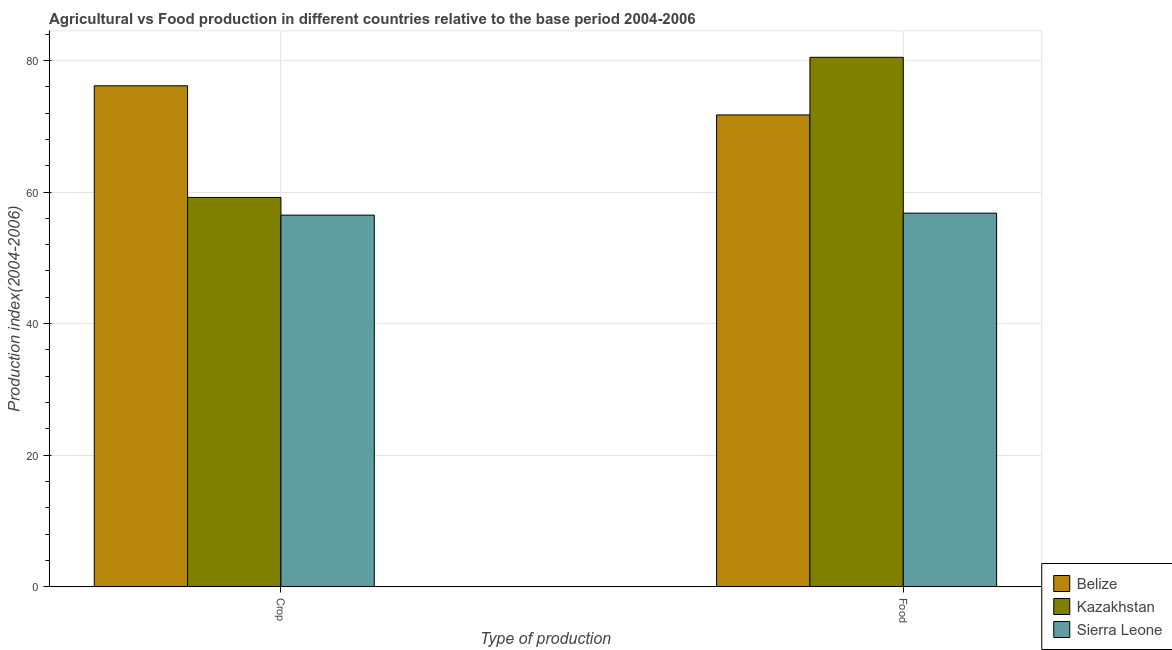What is the label of the 2nd group of bars from the left?
Your answer should be very brief. Food. What is the crop production index in Sierra Leone?
Your answer should be very brief. 56.49. Across all countries, what is the maximum food production index?
Your answer should be compact. 80.48. Across all countries, what is the minimum food production index?
Offer a very short reply. 56.79. In which country was the food production index maximum?
Your answer should be compact. Kazakhstan. In which country was the food production index minimum?
Your answer should be compact. Sierra Leone. What is the total crop production index in the graph?
Provide a short and direct response. 191.82. What is the difference between the food production index in Sierra Leone and that in Kazakhstan?
Make the answer very short. -23.69. What is the difference between the crop production index in Kazakhstan and the food production index in Sierra Leone?
Offer a terse response. 2.39. What is the average crop production index per country?
Your response must be concise. 63.94. What is the difference between the crop production index and food production index in Sierra Leone?
Your response must be concise. -0.3. What is the ratio of the food production index in Sierra Leone to that in Kazakhstan?
Your answer should be compact. 0.71. Is the crop production index in Sierra Leone less than that in Belize?
Offer a very short reply. Yes. What does the 2nd bar from the left in Food represents?
Offer a terse response. Kazakhstan. What does the 3rd bar from the right in Food represents?
Make the answer very short. Belize. How many bars are there?
Your answer should be compact. 6. How many countries are there in the graph?
Your answer should be very brief. 3. What is the difference between two consecutive major ticks on the Y-axis?
Your answer should be very brief. 20. Are the values on the major ticks of Y-axis written in scientific E-notation?
Offer a very short reply. No. Does the graph contain any zero values?
Your answer should be very brief. No. How many legend labels are there?
Offer a terse response. 3. What is the title of the graph?
Offer a terse response. Agricultural vs Food production in different countries relative to the base period 2004-2006. What is the label or title of the X-axis?
Give a very brief answer. Type of production. What is the label or title of the Y-axis?
Offer a terse response. Production index(2004-2006). What is the Production index(2004-2006) of Belize in Crop?
Offer a terse response. 76.15. What is the Production index(2004-2006) of Kazakhstan in Crop?
Give a very brief answer. 59.18. What is the Production index(2004-2006) of Sierra Leone in Crop?
Your answer should be very brief. 56.49. What is the Production index(2004-2006) of Belize in Food?
Keep it short and to the point. 71.72. What is the Production index(2004-2006) of Kazakhstan in Food?
Provide a short and direct response. 80.48. What is the Production index(2004-2006) in Sierra Leone in Food?
Your answer should be compact. 56.79. Across all Type of production, what is the maximum Production index(2004-2006) in Belize?
Keep it short and to the point. 76.15. Across all Type of production, what is the maximum Production index(2004-2006) in Kazakhstan?
Give a very brief answer. 80.48. Across all Type of production, what is the maximum Production index(2004-2006) in Sierra Leone?
Provide a succinct answer. 56.79. Across all Type of production, what is the minimum Production index(2004-2006) in Belize?
Your answer should be compact. 71.72. Across all Type of production, what is the minimum Production index(2004-2006) in Kazakhstan?
Ensure brevity in your answer.  59.18. Across all Type of production, what is the minimum Production index(2004-2006) in Sierra Leone?
Your answer should be very brief. 56.49. What is the total Production index(2004-2006) in Belize in the graph?
Your answer should be very brief. 147.87. What is the total Production index(2004-2006) in Kazakhstan in the graph?
Give a very brief answer. 139.66. What is the total Production index(2004-2006) in Sierra Leone in the graph?
Offer a very short reply. 113.28. What is the difference between the Production index(2004-2006) in Belize in Crop and that in Food?
Provide a succinct answer. 4.43. What is the difference between the Production index(2004-2006) of Kazakhstan in Crop and that in Food?
Provide a succinct answer. -21.3. What is the difference between the Production index(2004-2006) of Sierra Leone in Crop and that in Food?
Provide a succinct answer. -0.3. What is the difference between the Production index(2004-2006) in Belize in Crop and the Production index(2004-2006) in Kazakhstan in Food?
Provide a succinct answer. -4.33. What is the difference between the Production index(2004-2006) in Belize in Crop and the Production index(2004-2006) in Sierra Leone in Food?
Your answer should be very brief. 19.36. What is the difference between the Production index(2004-2006) of Kazakhstan in Crop and the Production index(2004-2006) of Sierra Leone in Food?
Offer a very short reply. 2.39. What is the average Production index(2004-2006) of Belize per Type of production?
Offer a very short reply. 73.94. What is the average Production index(2004-2006) in Kazakhstan per Type of production?
Ensure brevity in your answer.  69.83. What is the average Production index(2004-2006) of Sierra Leone per Type of production?
Your answer should be very brief. 56.64. What is the difference between the Production index(2004-2006) in Belize and Production index(2004-2006) in Kazakhstan in Crop?
Your answer should be very brief. 16.97. What is the difference between the Production index(2004-2006) of Belize and Production index(2004-2006) of Sierra Leone in Crop?
Provide a short and direct response. 19.66. What is the difference between the Production index(2004-2006) in Kazakhstan and Production index(2004-2006) in Sierra Leone in Crop?
Provide a short and direct response. 2.69. What is the difference between the Production index(2004-2006) in Belize and Production index(2004-2006) in Kazakhstan in Food?
Your answer should be very brief. -8.76. What is the difference between the Production index(2004-2006) of Belize and Production index(2004-2006) of Sierra Leone in Food?
Keep it short and to the point. 14.93. What is the difference between the Production index(2004-2006) of Kazakhstan and Production index(2004-2006) of Sierra Leone in Food?
Your answer should be compact. 23.69. What is the ratio of the Production index(2004-2006) of Belize in Crop to that in Food?
Provide a succinct answer. 1.06. What is the ratio of the Production index(2004-2006) in Kazakhstan in Crop to that in Food?
Offer a terse response. 0.74. What is the ratio of the Production index(2004-2006) of Sierra Leone in Crop to that in Food?
Give a very brief answer. 0.99. What is the difference between the highest and the second highest Production index(2004-2006) in Belize?
Provide a succinct answer. 4.43. What is the difference between the highest and the second highest Production index(2004-2006) in Kazakhstan?
Keep it short and to the point. 21.3. What is the difference between the highest and the lowest Production index(2004-2006) in Belize?
Offer a very short reply. 4.43. What is the difference between the highest and the lowest Production index(2004-2006) in Kazakhstan?
Provide a succinct answer. 21.3. What is the difference between the highest and the lowest Production index(2004-2006) in Sierra Leone?
Your response must be concise. 0.3. 